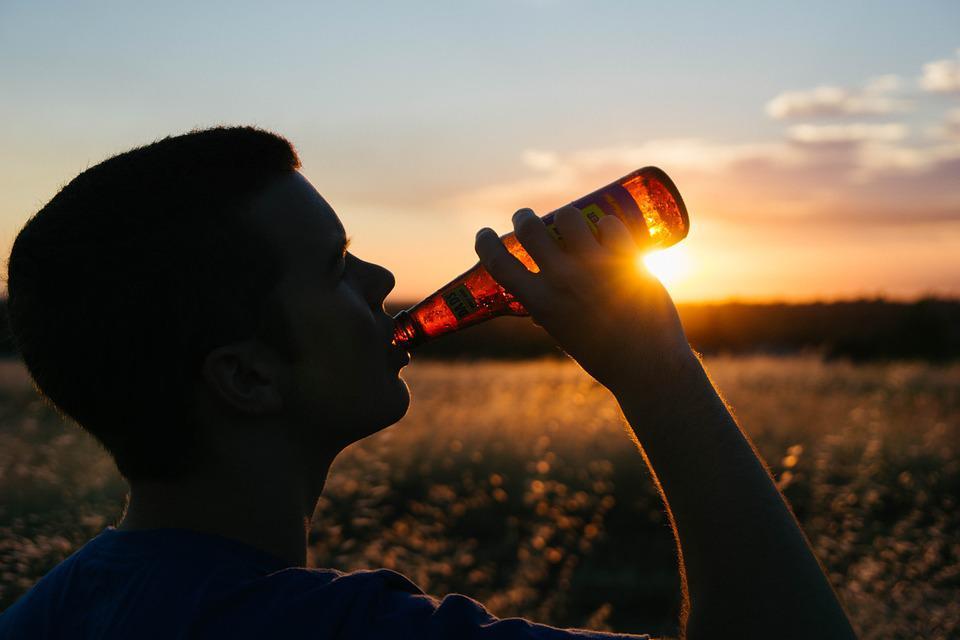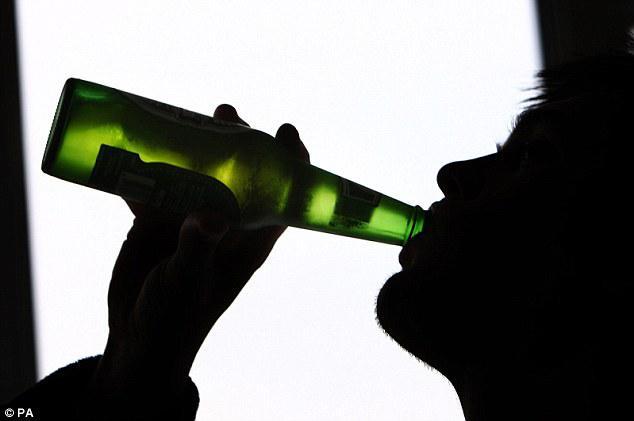The first image is the image on the left, the second image is the image on the right. Given the left and right images, does the statement "Two men are drinking and holding their beverage towards the left side of the image." hold true? Answer yes or no. No. The first image is the image on the left, the second image is the image on the right. For the images shown, is this caption "In at least one image there is a single male silhouette drink a glass of beer." true? Answer yes or no. No. 